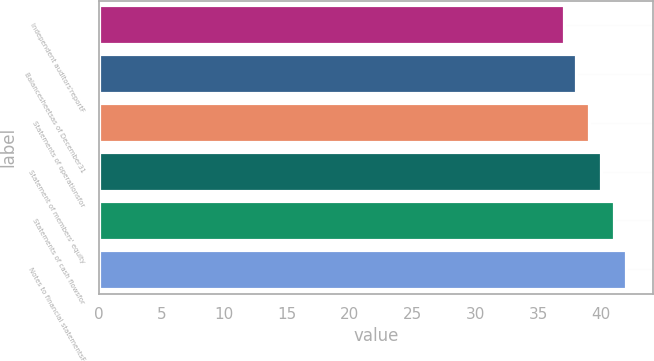<chart> <loc_0><loc_0><loc_500><loc_500><bar_chart><fcel>Independent auditors'reportF<fcel>Balancesheetsas of December31<fcel>Statements of operationsfor<fcel>Statement of members' equity<fcel>Statements of cash flowsfor<fcel>Notes to financial statementsF<nl><fcel>37<fcel>38<fcel>39<fcel>40<fcel>41<fcel>42<nl></chart> 